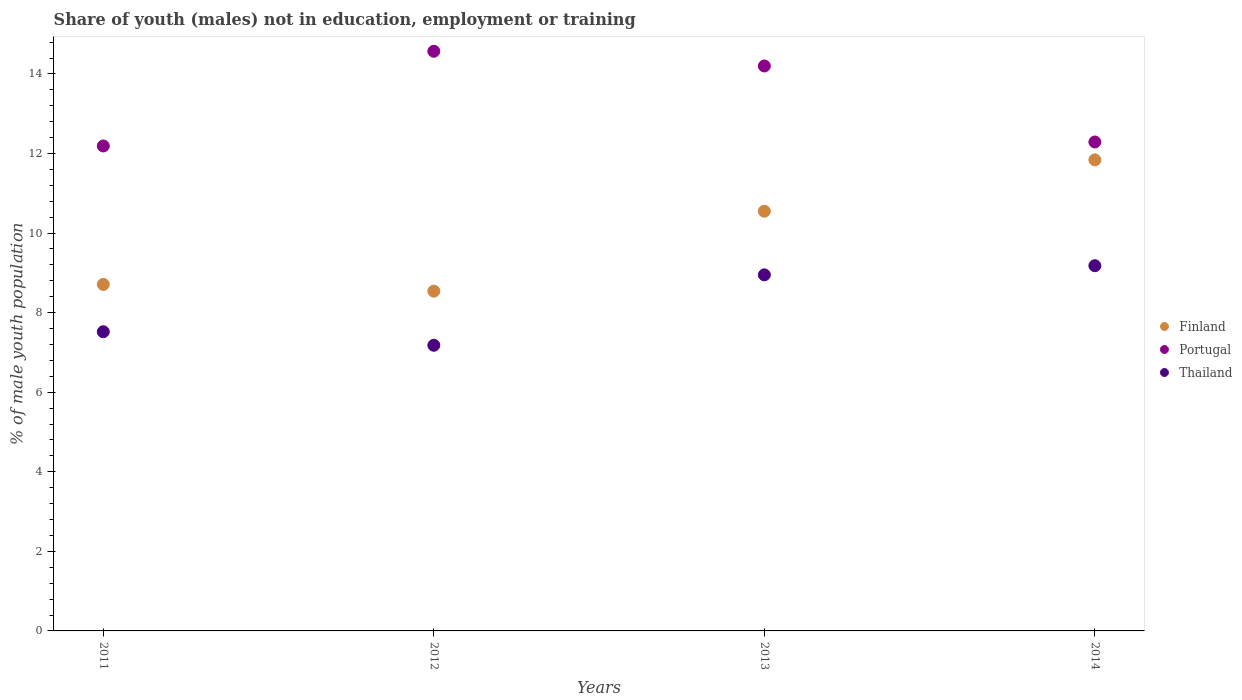How many different coloured dotlines are there?
Offer a terse response. 3. What is the percentage of unemployed males population in in Portugal in 2011?
Ensure brevity in your answer.  12.19. Across all years, what is the maximum percentage of unemployed males population in in Thailand?
Offer a terse response. 9.18. Across all years, what is the minimum percentage of unemployed males population in in Finland?
Offer a terse response. 8.54. In which year was the percentage of unemployed males population in in Finland minimum?
Make the answer very short. 2012. What is the total percentage of unemployed males population in in Finland in the graph?
Make the answer very short. 39.64. What is the difference between the percentage of unemployed males population in in Thailand in 2011 and that in 2014?
Your answer should be compact. -1.66. What is the difference between the percentage of unemployed males population in in Thailand in 2013 and the percentage of unemployed males population in in Portugal in 2012?
Give a very brief answer. -5.62. What is the average percentage of unemployed males population in in Finland per year?
Make the answer very short. 9.91. In the year 2014, what is the difference between the percentage of unemployed males population in in Thailand and percentage of unemployed males population in in Finland?
Keep it short and to the point. -2.66. What is the ratio of the percentage of unemployed males population in in Finland in 2013 to that in 2014?
Offer a very short reply. 0.89. What is the difference between the highest and the second highest percentage of unemployed males population in in Thailand?
Offer a very short reply. 0.23. What is the difference between the highest and the lowest percentage of unemployed males population in in Thailand?
Your response must be concise. 2. In how many years, is the percentage of unemployed males population in in Finland greater than the average percentage of unemployed males population in in Finland taken over all years?
Your answer should be compact. 2. Is it the case that in every year, the sum of the percentage of unemployed males population in in Finland and percentage of unemployed males population in in Portugal  is greater than the percentage of unemployed males population in in Thailand?
Provide a succinct answer. Yes. Is the percentage of unemployed males population in in Finland strictly greater than the percentage of unemployed males population in in Thailand over the years?
Keep it short and to the point. Yes. Is the percentage of unemployed males population in in Thailand strictly less than the percentage of unemployed males population in in Finland over the years?
Provide a succinct answer. Yes. How many dotlines are there?
Your answer should be compact. 3. How many years are there in the graph?
Your answer should be very brief. 4. Where does the legend appear in the graph?
Ensure brevity in your answer.  Center right. How many legend labels are there?
Offer a very short reply. 3. How are the legend labels stacked?
Your answer should be very brief. Vertical. What is the title of the graph?
Give a very brief answer. Share of youth (males) not in education, employment or training. What is the label or title of the X-axis?
Your answer should be very brief. Years. What is the label or title of the Y-axis?
Ensure brevity in your answer.  % of male youth population. What is the % of male youth population of Finland in 2011?
Keep it short and to the point. 8.71. What is the % of male youth population of Portugal in 2011?
Keep it short and to the point. 12.19. What is the % of male youth population of Thailand in 2011?
Your answer should be compact. 7.52. What is the % of male youth population of Finland in 2012?
Keep it short and to the point. 8.54. What is the % of male youth population of Portugal in 2012?
Your response must be concise. 14.57. What is the % of male youth population of Thailand in 2012?
Keep it short and to the point. 7.18. What is the % of male youth population of Finland in 2013?
Offer a very short reply. 10.55. What is the % of male youth population in Portugal in 2013?
Your answer should be very brief. 14.2. What is the % of male youth population of Thailand in 2013?
Offer a terse response. 8.95. What is the % of male youth population in Finland in 2014?
Your response must be concise. 11.84. What is the % of male youth population in Portugal in 2014?
Ensure brevity in your answer.  12.29. What is the % of male youth population of Thailand in 2014?
Offer a terse response. 9.18. Across all years, what is the maximum % of male youth population in Finland?
Offer a very short reply. 11.84. Across all years, what is the maximum % of male youth population in Portugal?
Keep it short and to the point. 14.57. Across all years, what is the maximum % of male youth population of Thailand?
Ensure brevity in your answer.  9.18. Across all years, what is the minimum % of male youth population of Finland?
Provide a succinct answer. 8.54. Across all years, what is the minimum % of male youth population in Portugal?
Give a very brief answer. 12.19. Across all years, what is the minimum % of male youth population of Thailand?
Make the answer very short. 7.18. What is the total % of male youth population of Finland in the graph?
Your response must be concise. 39.64. What is the total % of male youth population of Portugal in the graph?
Your answer should be compact. 53.25. What is the total % of male youth population in Thailand in the graph?
Your response must be concise. 32.83. What is the difference between the % of male youth population of Finland in 2011 and that in 2012?
Offer a very short reply. 0.17. What is the difference between the % of male youth population of Portugal in 2011 and that in 2012?
Offer a very short reply. -2.38. What is the difference between the % of male youth population in Thailand in 2011 and that in 2012?
Your answer should be very brief. 0.34. What is the difference between the % of male youth population of Finland in 2011 and that in 2013?
Your answer should be compact. -1.84. What is the difference between the % of male youth population in Portugal in 2011 and that in 2013?
Provide a succinct answer. -2.01. What is the difference between the % of male youth population in Thailand in 2011 and that in 2013?
Offer a very short reply. -1.43. What is the difference between the % of male youth population in Finland in 2011 and that in 2014?
Your answer should be compact. -3.13. What is the difference between the % of male youth population of Thailand in 2011 and that in 2014?
Offer a very short reply. -1.66. What is the difference between the % of male youth population in Finland in 2012 and that in 2013?
Your answer should be very brief. -2.01. What is the difference between the % of male youth population in Portugal in 2012 and that in 2013?
Ensure brevity in your answer.  0.37. What is the difference between the % of male youth population in Thailand in 2012 and that in 2013?
Provide a short and direct response. -1.77. What is the difference between the % of male youth population in Portugal in 2012 and that in 2014?
Provide a short and direct response. 2.28. What is the difference between the % of male youth population in Finland in 2013 and that in 2014?
Offer a very short reply. -1.29. What is the difference between the % of male youth population of Portugal in 2013 and that in 2014?
Provide a short and direct response. 1.91. What is the difference between the % of male youth population in Thailand in 2013 and that in 2014?
Your answer should be compact. -0.23. What is the difference between the % of male youth population in Finland in 2011 and the % of male youth population in Portugal in 2012?
Your answer should be very brief. -5.86. What is the difference between the % of male youth population in Finland in 2011 and the % of male youth population in Thailand in 2012?
Provide a short and direct response. 1.53. What is the difference between the % of male youth population in Portugal in 2011 and the % of male youth population in Thailand in 2012?
Make the answer very short. 5.01. What is the difference between the % of male youth population of Finland in 2011 and the % of male youth population of Portugal in 2013?
Provide a short and direct response. -5.49. What is the difference between the % of male youth population of Finland in 2011 and the % of male youth population of Thailand in 2013?
Ensure brevity in your answer.  -0.24. What is the difference between the % of male youth population in Portugal in 2011 and the % of male youth population in Thailand in 2013?
Your answer should be compact. 3.24. What is the difference between the % of male youth population in Finland in 2011 and the % of male youth population in Portugal in 2014?
Offer a very short reply. -3.58. What is the difference between the % of male youth population in Finland in 2011 and the % of male youth population in Thailand in 2014?
Ensure brevity in your answer.  -0.47. What is the difference between the % of male youth population of Portugal in 2011 and the % of male youth population of Thailand in 2014?
Ensure brevity in your answer.  3.01. What is the difference between the % of male youth population in Finland in 2012 and the % of male youth population in Portugal in 2013?
Provide a succinct answer. -5.66. What is the difference between the % of male youth population of Finland in 2012 and the % of male youth population of Thailand in 2013?
Make the answer very short. -0.41. What is the difference between the % of male youth population in Portugal in 2012 and the % of male youth population in Thailand in 2013?
Make the answer very short. 5.62. What is the difference between the % of male youth population in Finland in 2012 and the % of male youth population in Portugal in 2014?
Your answer should be compact. -3.75. What is the difference between the % of male youth population in Finland in 2012 and the % of male youth population in Thailand in 2014?
Offer a very short reply. -0.64. What is the difference between the % of male youth population in Portugal in 2012 and the % of male youth population in Thailand in 2014?
Make the answer very short. 5.39. What is the difference between the % of male youth population in Finland in 2013 and the % of male youth population in Portugal in 2014?
Your answer should be compact. -1.74. What is the difference between the % of male youth population in Finland in 2013 and the % of male youth population in Thailand in 2014?
Provide a short and direct response. 1.37. What is the difference between the % of male youth population in Portugal in 2013 and the % of male youth population in Thailand in 2014?
Offer a terse response. 5.02. What is the average % of male youth population of Finland per year?
Your answer should be compact. 9.91. What is the average % of male youth population in Portugal per year?
Offer a very short reply. 13.31. What is the average % of male youth population in Thailand per year?
Offer a very short reply. 8.21. In the year 2011, what is the difference between the % of male youth population of Finland and % of male youth population of Portugal?
Your answer should be very brief. -3.48. In the year 2011, what is the difference between the % of male youth population in Finland and % of male youth population in Thailand?
Give a very brief answer. 1.19. In the year 2011, what is the difference between the % of male youth population in Portugal and % of male youth population in Thailand?
Offer a terse response. 4.67. In the year 2012, what is the difference between the % of male youth population of Finland and % of male youth population of Portugal?
Your answer should be compact. -6.03. In the year 2012, what is the difference between the % of male youth population in Finland and % of male youth population in Thailand?
Offer a very short reply. 1.36. In the year 2012, what is the difference between the % of male youth population of Portugal and % of male youth population of Thailand?
Your response must be concise. 7.39. In the year 2013, what is the difference between the % of male youth population of Finland and % of male youth population of Portugal?
Give a very brief answer. -3.65. In the year 2013, what is the difference between the % of male youth population of Finland and % of male youth population of Thailand?
Give a very brief answer. 1.6. In the year 2013, what is the difference between the % of male youth population of Portugal and % of male youth population of Thailand?
Provide a short and direct response. 5.25. In the year 2014, what is the difference between the % of male youth population of Finland and % of male youth population of Portugal?
Make the answer very short. -0.45. In the year 2014, what is the difference between the % of male youth population of Finland and % of male youth population of Thailand?
Offer a terse response. 2.66. In the year 2014, what is the difference between the % of male youth population of Portugal and % of male youth population of Thailand?
Make the answer very short. 3.11. What is the ratio of the % of male youth population in Finland in 2011 to that in 2012?
Offer a very short reply. 1.02. What is the ratio of the % of male youth population of Portugal in 2011 to that in 2012?
Ensure brevity in your answer.  0.84. What is the ratio of the % of male youth population of Thailand in 2011 to that in 2012?
Your answer should be very brief. 1.05. What is the ratio of the % of male youth population of Finland in 2011 to that in 2013?
Ensure brevity in your answer.  0.83. What is the ratio of the % of male youth population of Portugal in 2011 to that in 2013?
Offer a very short reply. 0.86. What is the ratio of the % of male youth population of Thailand in 2011 to that in 2013?
Keep it short and to the point. 0.84. What is the ratio of the % of male youth population of Finland in 2011 to that in 2014?
Give a very brief answer. 0.74. What is the ratio of the % of male youth population of Portugal in 2011 to that in 2014?
Provide a succinct answer. 0.99. What is the ratio of the % of male youth population in Thailand in 2011 to that in 2014?
Provide a succinct answer. 0.82. What is the ratio of the % of male youth population of Finland in 2012 to that in 2013?
Your response must be concise. 0.81. What is the ratio of the % of male youth population of Portugal in 2012 to that in 2013?
Keep it short and to the point. 1.03. What is the ratio of the % of male youth population of Thailand in 2012 to that in 2013?
Provide a short and direct response. 0.8. What is the ratio of the % of male youth population in Finland in 2012 to that in 2014?
Provide a succinct answer. 0.72. What is the ratio of the % of male youth population of Portugal in 2012 to that in 2014?
Provide a succinct answer. 1.19. What is the ratio of the % of male youth population of Thailand in 2012 to that in 2014?
Ensure brevity in your answer.  0.78. What is the ratio of the % of male youth population in Finland in 2013 to that in 2014?
Provide a short and direct response. 0.89. What is the ratio of the % of male youth population of Portugal in 2013 to that in 2014?
Offer a very short reply. 1.16. What is the ratio of the % of male youth population in Thailand in 2013 to that in 2014?
Your answer should be very brief. 0.97. What is the difference between the highest and the second highest % of male youth population of Finland?
Provide a succinct answer. 1.29. What is the difference between the highest and the second highest % of male youth population in Portugal?
Your answer should be compact. 0.37. What is the difference between the highest and the second highest % of male youth population of Thailand?
Your answer should be compact. 0.23. What is the difference between the highest and the lowest % of male youth population of Finland?
Ensure brevity in your answer.  3.3. What is the difference between the highest and the lowest % of male youth population of Portugal?
Give a very brief answer. 2.38. What is the difference between the highest and the lowest % of male youth population in Thailand?
Your answer should be very brief. 2. 